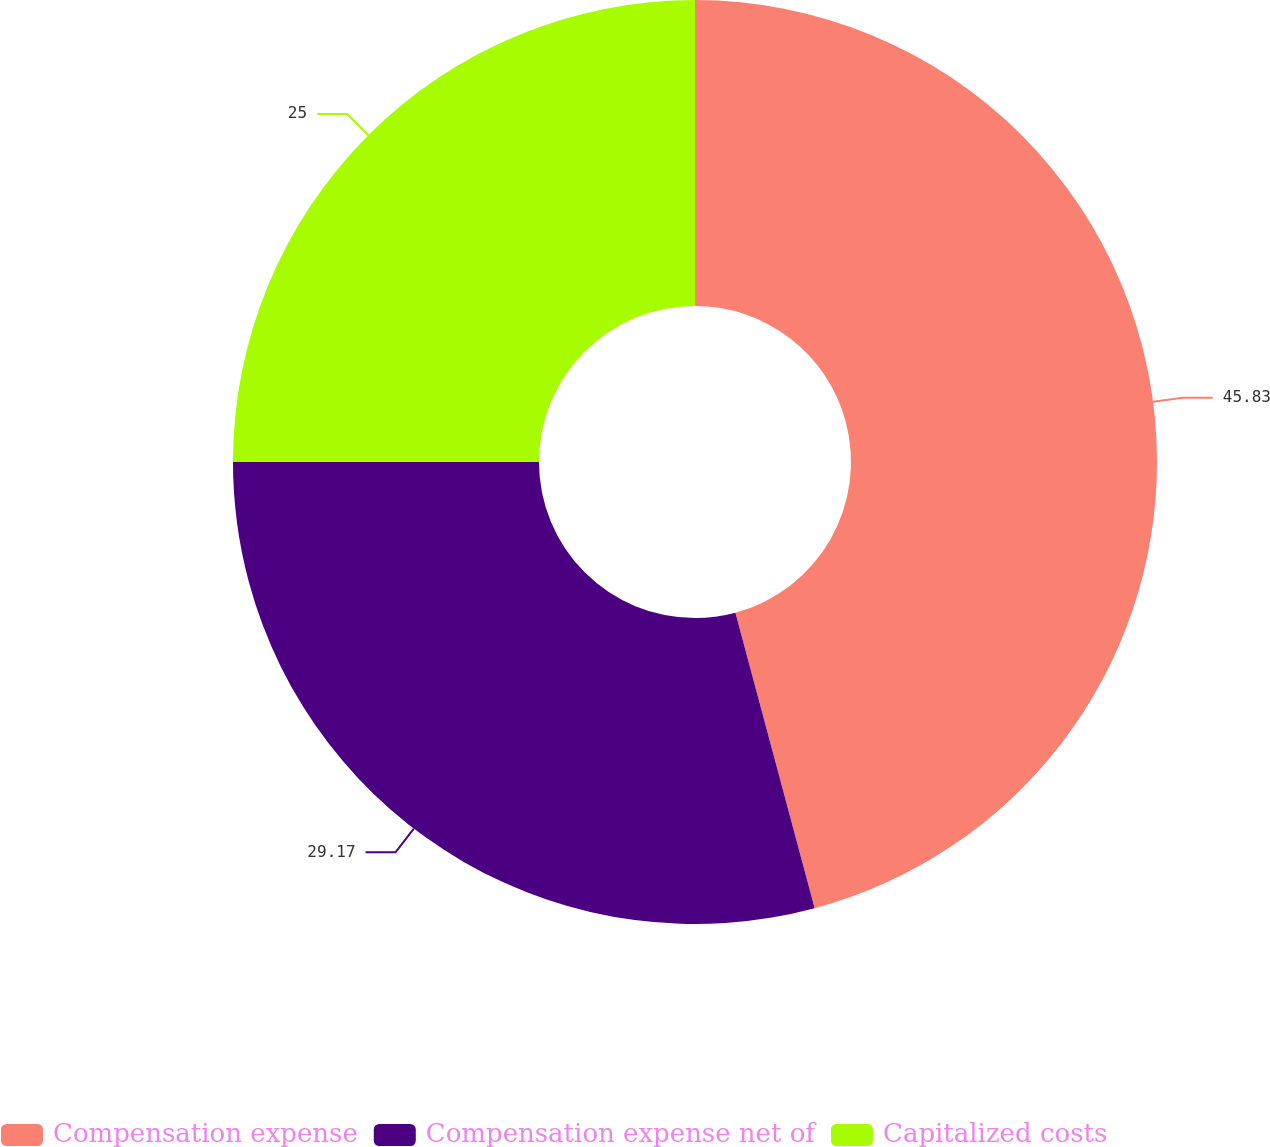<chart> <loc_0><loc_0><loc_500><loc_500><pie_chart><fcel>Compensation expense<fcel>Compensation expense net of<fcel>Capitalized costs<nl><fcel>45.83%<fcel>29.17%<fcel>25.0%<nl></chart> 